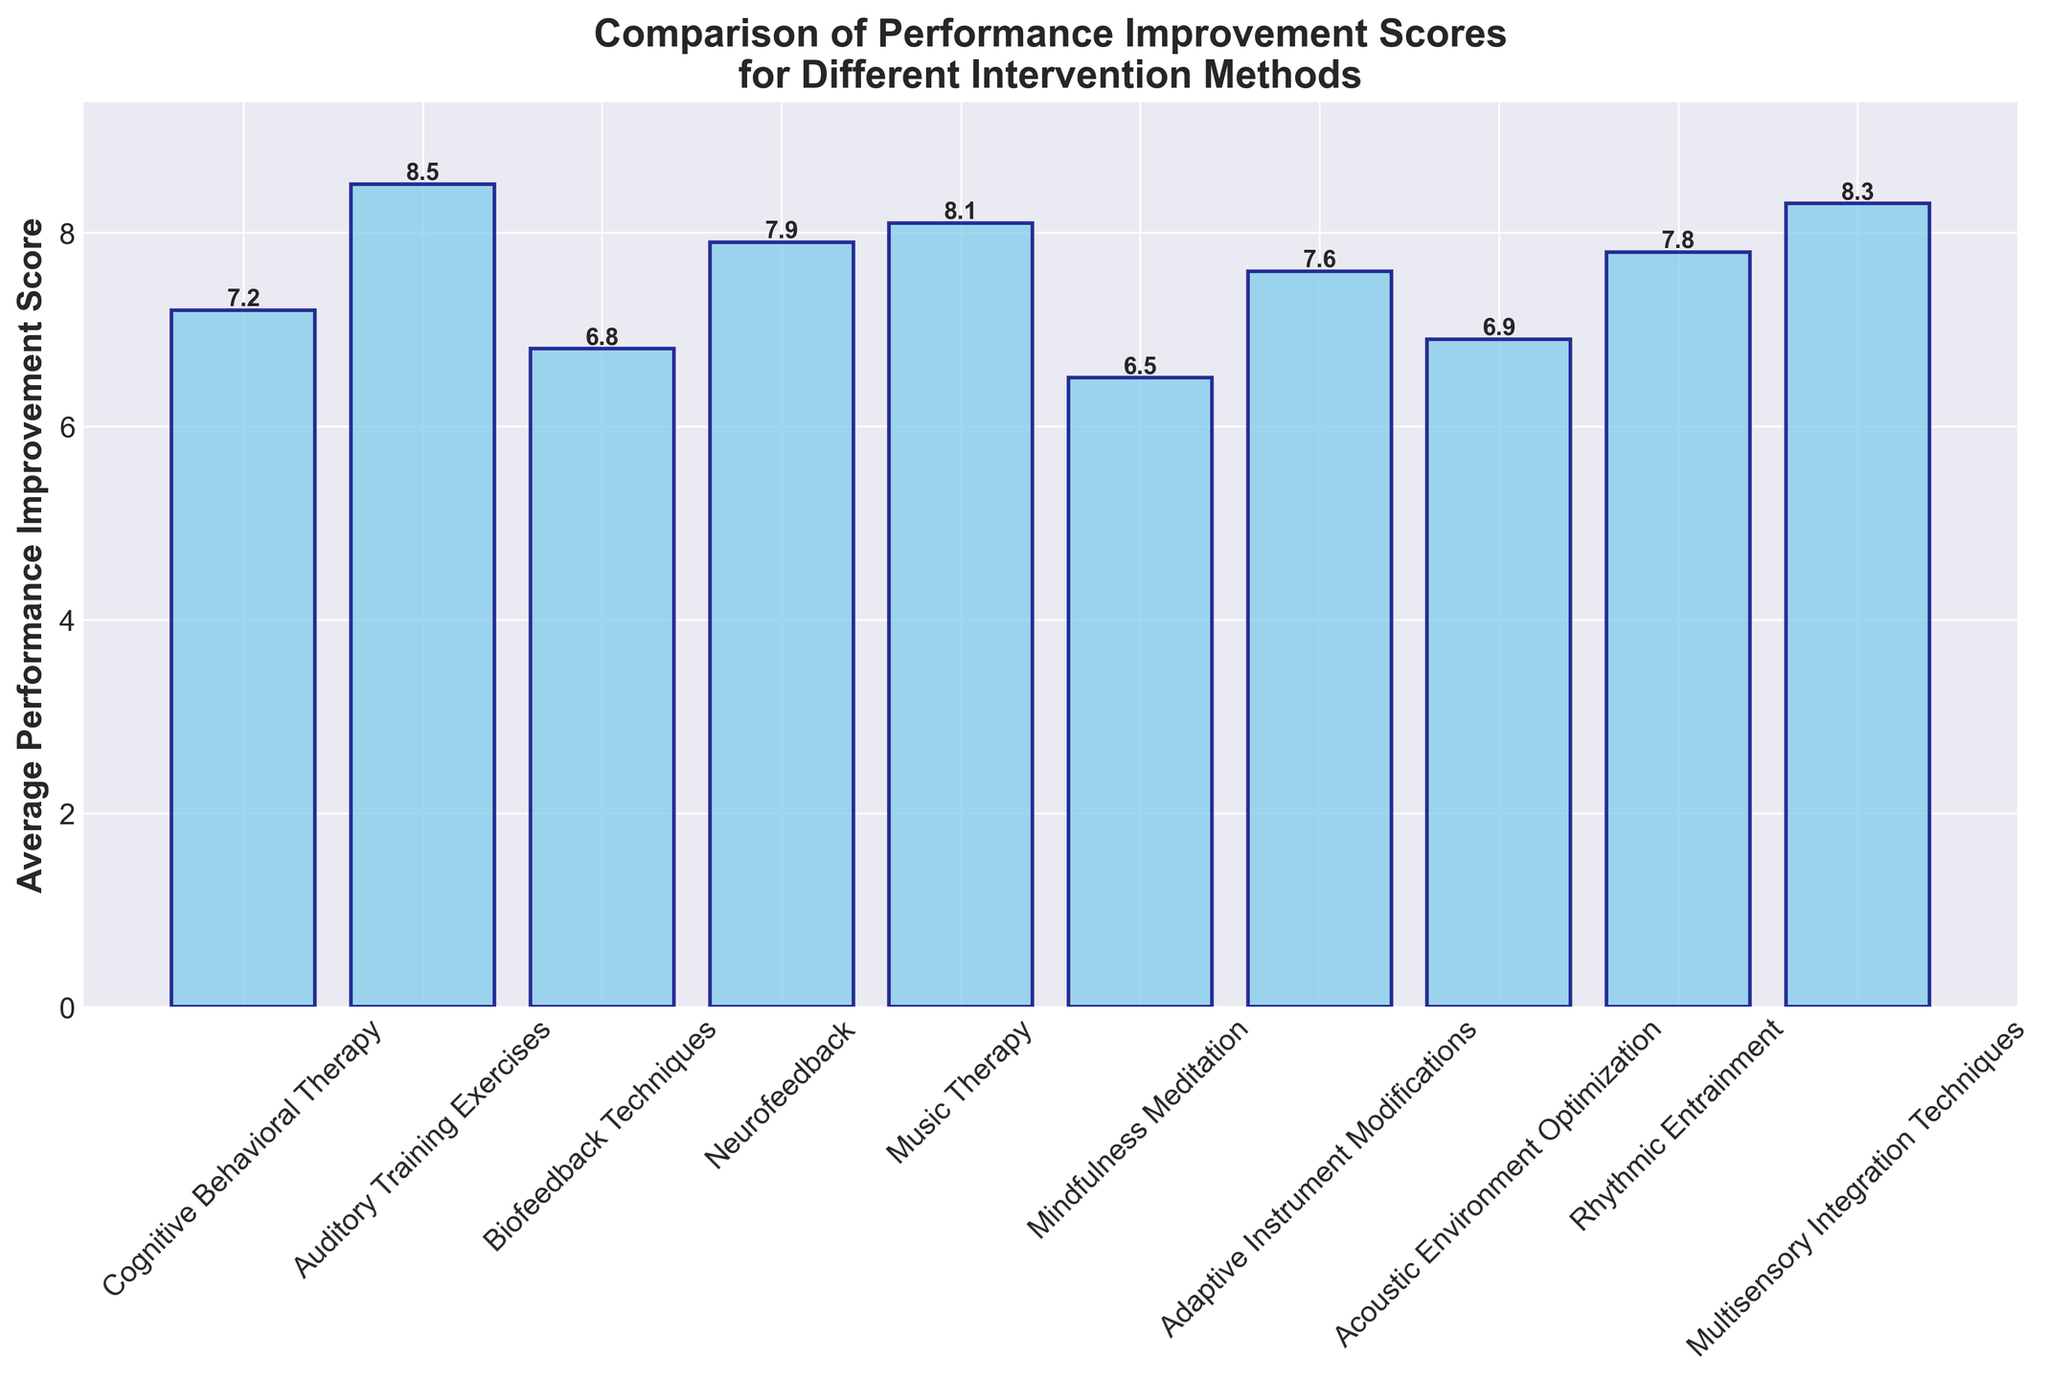Which intervention method has the highest average performance improvement score? We look at the heights of the bars in the bar chart and find the tallest one. The method with the highest bar is "Auditory Training Exercises".
Answer: Auditory Training Exercises Which intervention method has the lowest average performance improvement score? We look at the heights of the bars in the bar chart and find the shortest one. The method with the lowest bar is "Mindfulness Meditation".
Answer: Mindfulness Meditation How much higher is the average performance improvement score for Music Therapy compared to Biofeedback Techniques? We find the heights of the bars for both intervention methods. Music Therapy has a score of 8.1 and Biofeedback Techniques has a score of 6.8. The difference is 8.1 - 6.8 = 1.3.
Answer: 1.3 What is the average score of the top three intervention methods? We identify the top three methods with the highest bars: Auditory Training Exercises (8.5), Multisensory Integration Techniques (8.3), and Music Therapy (8.1). The average is calculated as (8.5 + 8.3 + 8.1) / 3 = 8.3.
Answer: 8.3 Which intervention methods have an average performance improvement score greater than 7.5? We find all methods with bars taller than the 7.5 mark. These methods are Auditory Training Exercises, Multisensory Integration Techniques, Music Therapy, and Rhythmic Entrainment.
Answer: Auditory Training Exercises, Multisensory Integration Techniques, Music Therapy, Rhythmic Entrainment What is the range of the average performance improvement scores across all intervention methods? We find the highest score (8.5 from Auditory Training Exercises) and the lowest score (6.5 from Mindfulness Meditation). The range is 8.5 - 6.5 = 2.0.
Answer: 2.0 Is the height of the bar for Neurofeedback closer to Cognitive Behavioral Therapy or Adaptive Instrument Modifications? We compare the height of the bar for Neurofeedback (7.9) with those for Cognitive Behavioral Therapy (7.2) and Adaptive Instrument Modifications (7.6). The difference from Neurofeedback to Cognitive Behavioral Therapy is 0.7 and to Adaptive Instrument Modifications is 0.3. Neurofeedback is closer to Adaptive Instrument Modifications.
Answer: Adaptive Instrument Modifications 